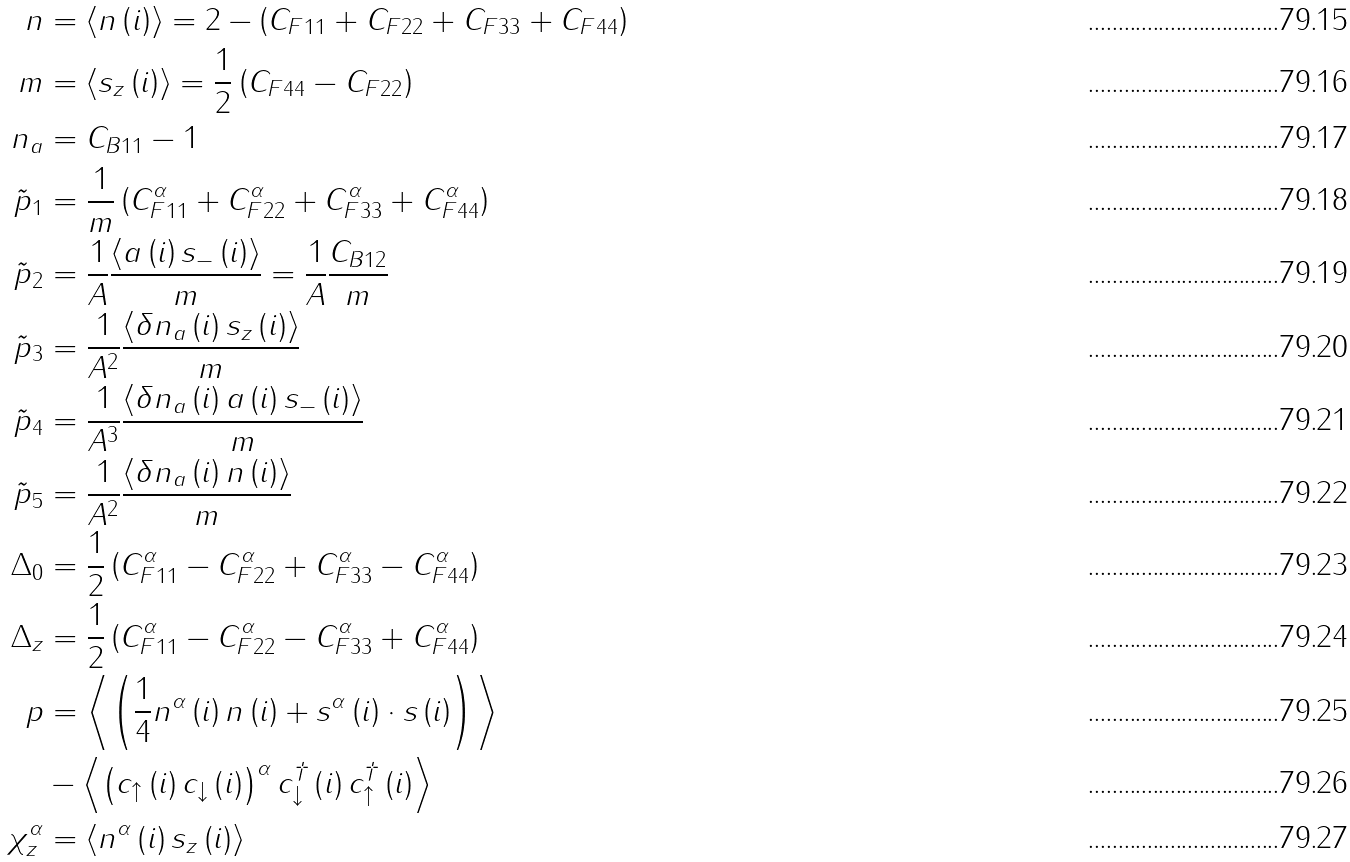Convert formula to latex. <formula><loc_0><loc_0><loc_500><loc_500>n & = \left \langle n \left ( i \right ) \right \rangle = 2 - \left ( C _ { F 1 1 } + C _ { F 2 2 } + C _ { F 3 3 } + C _ { F 4 4 } \right ) \\ m & = \left \langle s _ { z } \left ( i \right ) \right \rangle = \frac { 1 } { 2 } \left ( C _ { F 4 4 } - C _ { F 2 2 } \right ) \\ n _ { a } & = C _ { B 1 1 } - 1 \\ \tilde { p } _ { 1 } & = \frac { 1 } { m } \left ( C _ { F 1 1 } ^ { \alpha } + C _ { F 2 2 } ^ { \alpha } + C _ { F 3 3 } ^ { \alpha } + C _ { F 4 4 } ^ { \alpha } \right ) \\ \tilde { p } _ { 2 } & = \frac { 1 } { A } \frac { \left \langle a \left ( i \right ) s _ { - } \left ( i \right ) \right \rangle } { m } = \frac { 1 } { A } \frac { C _ { B 1 2 } } { m } \\ \tilde { p } _ { 3 } & = \frac { 1 } { A ^ { 2 } } \frac { \left \langle \delta n _ { a } \left ( i \right ) s _ { z } \left ( i \right ) \right \rangle } { m } \\ \tilde { p } _ { 4 } & = \frac { 1 } { A ^ { 3 } } \frac { \left \langle \delta n _ { a } \left ( i \right ) a \left ( i \right ) s _ { - } \left ( i \right ) \right \rangle } { m } \\ \tilde { p } _ { 5 } & = \frac { 1 } { A ^ { 2 } } \frac { \left \langle \delta n _ { a } \left ( i \right ) n \left ( i \right ) \right \rangle } { m } \\ \Delta _ { 0 } & = \frac { 1 } { 2 } \left ( C _ { F 1 1 } ^ { \alpha } - C _ { F 2 2 } ^ { \alpha } + C _ { F 3 3 } ^ { \alpha } - C _ { F 4 4 } ^ { \alpha } \right ) \\ \Delta _ { z } & = \frac { 1 } { 2 } \left ( C _ { F 1 1 } ^ { \alpha } - C _ { F 2 2 } ^ { \alpha } - C _ { F 3 3 } ^ { \alpha } + C _ { F 4 4 } ^ { \alpha } \right ) \\ p & = \left \langle \left ( \frac { 1 } { 4 } n ^ { \alpha } \left ( i \right ) n \left ( i \right ) + s ^ { \alpha } \left ( i \right ) \cdot s \left ( i \right ) \right ) \right \rangle \\ & - \left \langle \left ( c _ { \uparrow } \left ( i \right ) c _ { \downarrow } \left ( i \right ) \right ) ^ { \alpha } c _ { \downarrow } ^ { \dagger } \left ( i \right ) c _ { \uparrow } ^ { \dagger } \left ( i \right ) \right \rangle \\ \chi _ { z } ^ { \alpha } & = \left \langle n ^ { \alpha } \left ( i \right ) s _ { z } \left ( i \right ) \right \rangle</formula> 